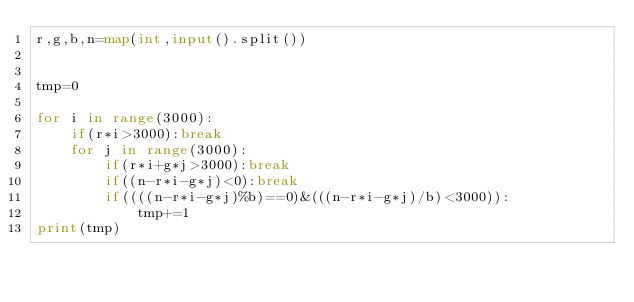<code> <loc_0><loc_0><loc_500><loc_500><_Python_>r,g,b,n=map(int,input().split())


tmp=0

for i in range(3000):
    if(r*i>3000):break
    for j in range(3000):
        if(r*i+g*j>3000):break
        if((n-r*i-g*j)<0):break
        if((((n-r*i-g*j)%b)==0)&(((n-r*i-g*j)/b)<3000)):
            tmp+=1
print(tmp)</code> 